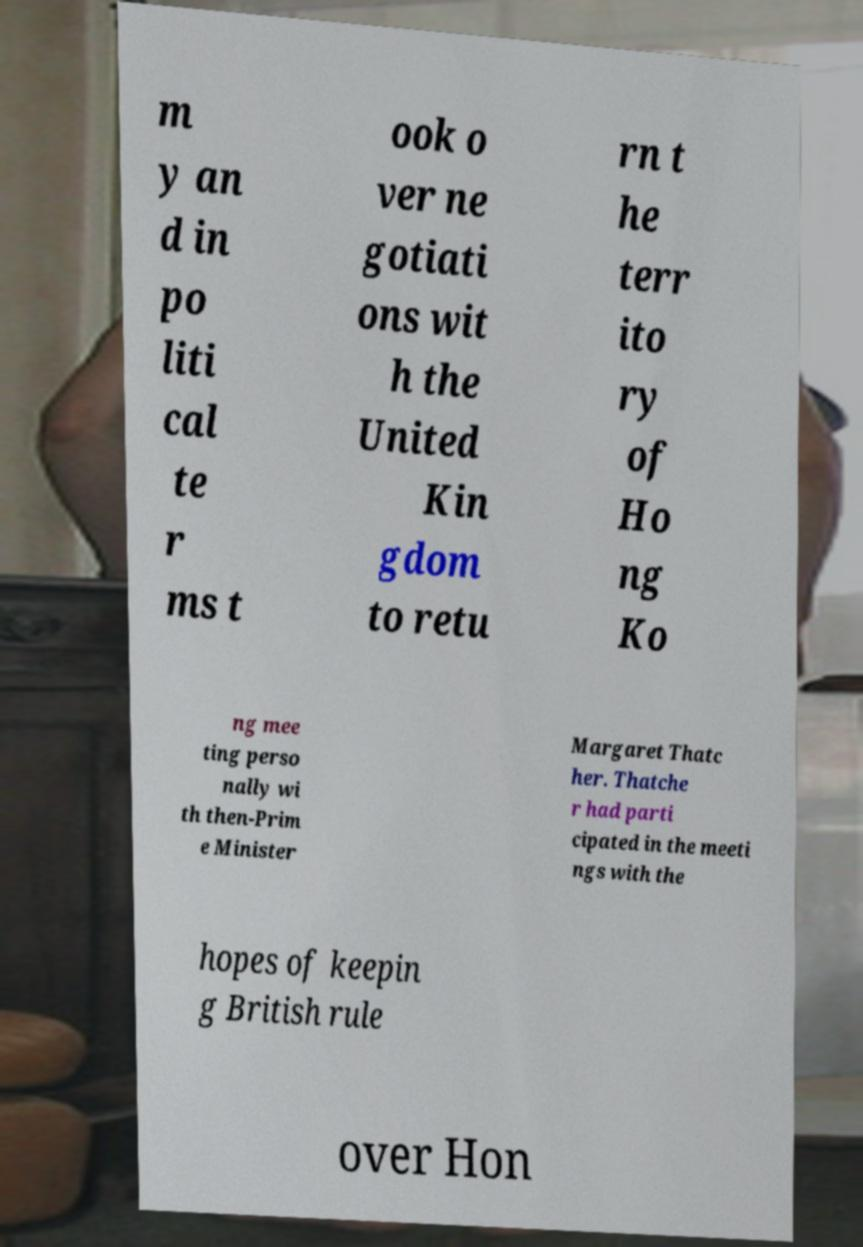Can you read and provide the text displayed in the image?This photo seems to have some interesting text. Can you extract and type it out for me? m y an d in po liti cal te r ms t ook o ver ne gotiati ons wit h the United Kin gdom to retu rn t he terr ito ry of Ho ng Ko ng mee ting perso nally wi th then-Prim e Minister Margaret Thatc her. Thatche r had parti cipated in the meeti ngs with the hopes of keepin g British rule over Hon 